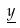Convert formula to latex. <formula><loc_0><loc_0><loc_500><loc_500>\underline { y }</formula> 